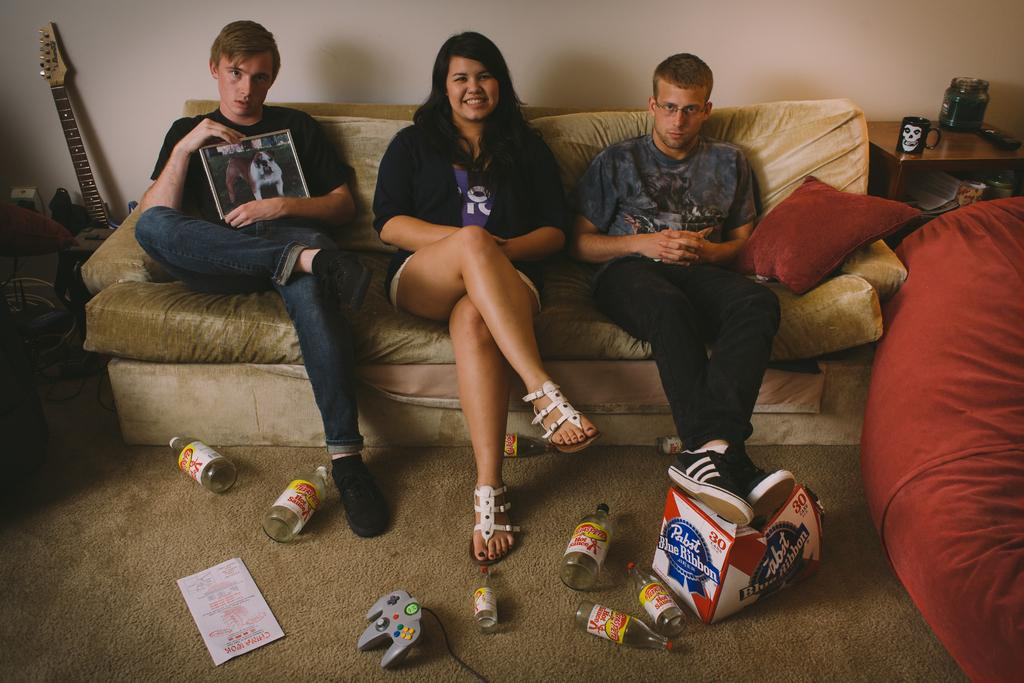Provide a one-sentence caption for the provided image. A boy props his feet on a box that reads "Pabst Blue Ribbon.". 